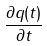<formula> <loc_0><loc_0><loc_500><loc_500>\frac { \partial q ( t ) } { \partial t }</formula> 